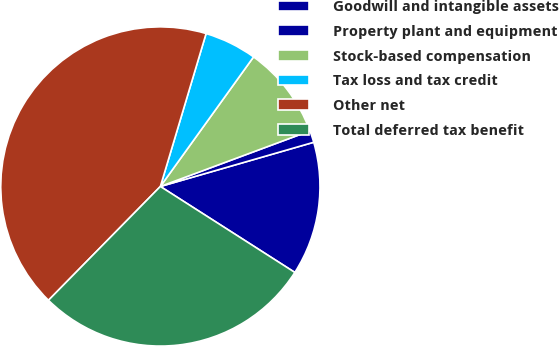Convert chart to OTSL. <chart><loc_0><loc_0><loc_500><loc_500><pie_chart><fcel>Goodwill and intangible assets<fcel>Property plant and equipment<fcel>Stock-based compensation<fcel>Tax loss and tax credit<fcel>Other net<fcel>Total deferred tax benefit<nl><fcel>13.52%<fcel>1.2%<fcel>9.41%<fcel>5.3%<fcel>42.26%<fcel>28.31%<nl></chart> 